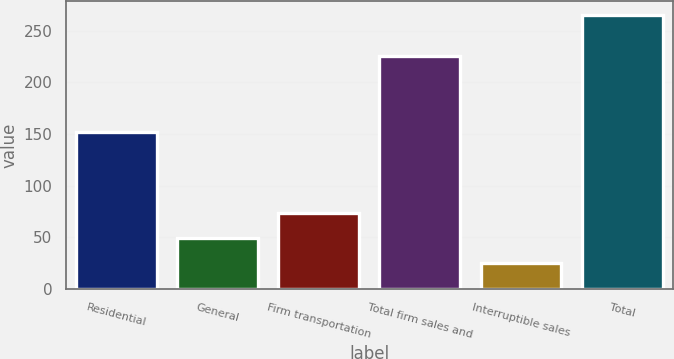Convert chart to OTSL. <chart><loc_0><loc_0><loc_500><loc_500><bar_chart><fcel>Residential<fcel>General<fcel>Firm transportation<fcel>Total firm sales and<fcel>Interruptible sales<fcel>Total<nl><fcel>152<fcel>49<fcel>73<fcel>225<fcel>25<fcel>265<nl></chart> 